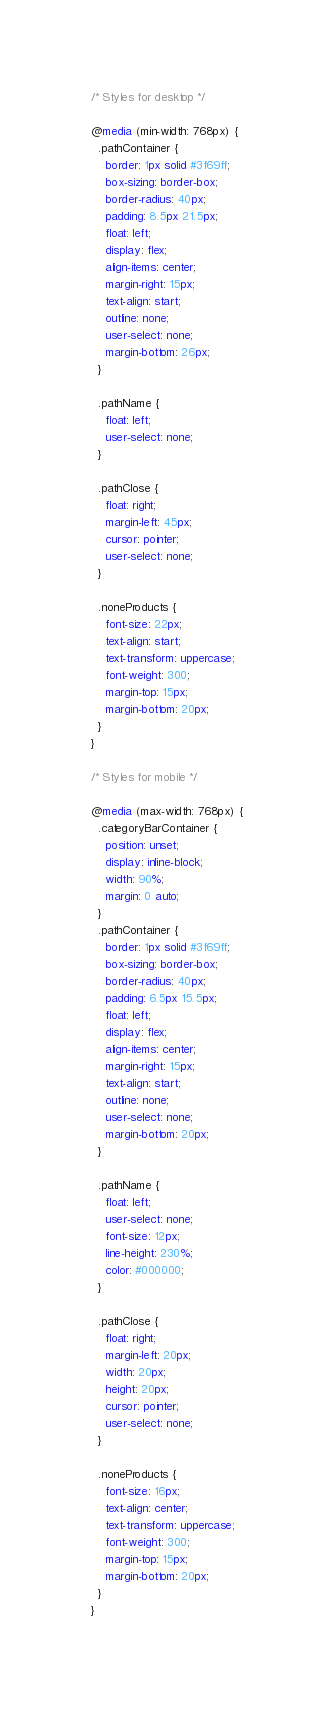<code> <loc_0><loc_0><loc_500><loc_500><_CSS_>/* Styles for desktop */

@media (min-width: 768px) {
  .pathContainer {
    border: 1px solid #3f69ff;
    box-sizing: border-box;
    border-radius: 40px;
    padding: 8.5px 21.5px;
    float: left;
    display: flex;
    align-items: center;
    margin-right: 15px;
    text-align: start;
    outline: none;
    user-select: none;
    margin-bottom: 26px;
  }

  .pathName {
    float: left;
    user-select: none;
  }

  .pathClose {
    float: right;
    margin-left: 45px;
    cursor: pointer;
    user-select: none;
  }

  .noneProducts {
    font-size: 22px;
    text-align: start;
    text-transform: uppercase;
    font-weight: 300;
    margin-top: 15px;
    margin-bottom: 20px;
  }
}

/* Styles for mobile */

@media (max-width: 768px) {
  .categoryBarContainer {
    position: unset;
    display: inline-block;
    width: 90%;
    margin: 0 auto;
  }
  .pathContainer {
    border: 1px solid #3f69ff;
    box-sizing: border-box;
    border-radius: 40px;
    padding: 6.5px 15.5px;
    float: left;
    display: flex;
    align-items: center;
    margin-right: 15px;
    text-align: start;
    outline: none;
    user-select: none;
    margin-bottom: 20px;
  }

  .pathName {
    float: left;
    user-select: none;
    font-size: 12px;
    line-height: 230%;
    color: #000000;
  }

  .pathClose {
    float: right;
    margin-left: 20px;
    width: 20px;
    height: 20px;
    cursor: pointer;
    user-select: none;
  }

  .noneProducts {
    font-size: 16px;
    text-align: center;
    text-transform: uppercase;
    font-weight: 300;
    margin-top: 15px;
    margin-bottom: 20px;
  }
}
</code> 